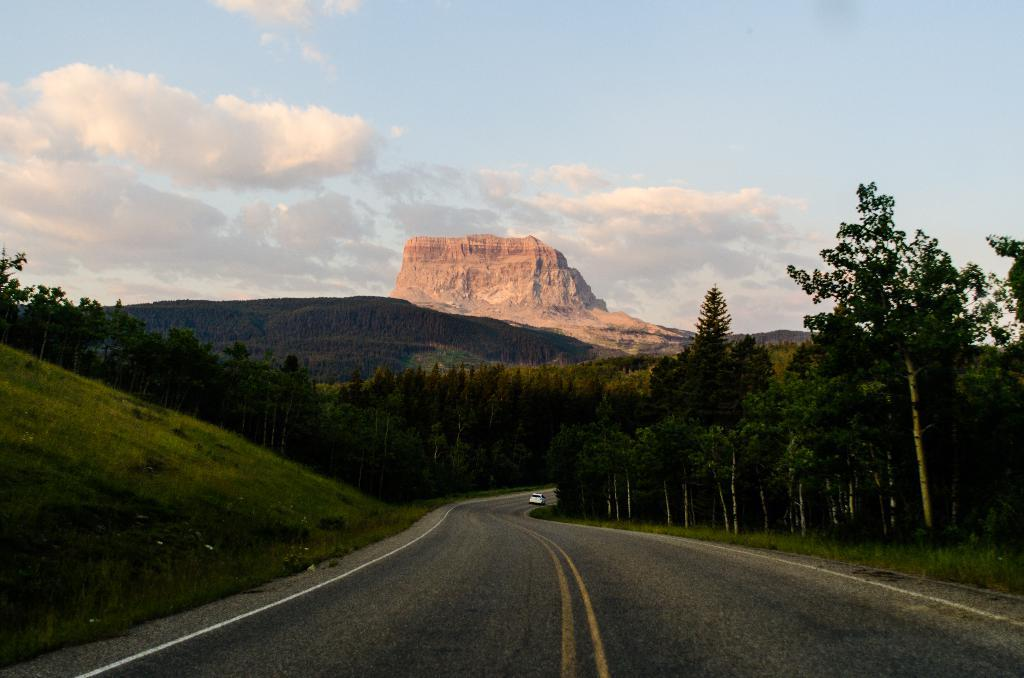What is the main subject of the image? The main subject of the image is a car. Where is the car located in the image? The car is on the road in the image. What can be seen in the background of the image? In the background of the image, there are clouds, hills, trees, and grass. What type of guitar can be seen being played on the trail in the image? There is no guitar or trail present in the image; it features a car on the road with a background of clouds, hills, trees, and grass. 